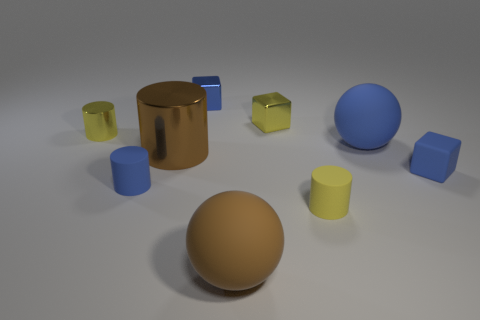Add 1 small blue matte things. How many objects exist? 10 Subtract all yellow shiny cylinders. How many cylinders are left? 3 Subtract all red cylinders. Subtract all cyan blocks. How many cylinders are left? 4 Subtract all blocks. How many objects are left? 6 Add 9 brown cylinders. How many brown cylinders exist? 10 Subtract 0 red blocks. How many objects are left? 9 Subtract all large blue balls. Subtract all small yellow metal blocks. How many objects are left? 7 Add 5 small blue matte cylinders. How many small blue matte cylinders are left? 6 